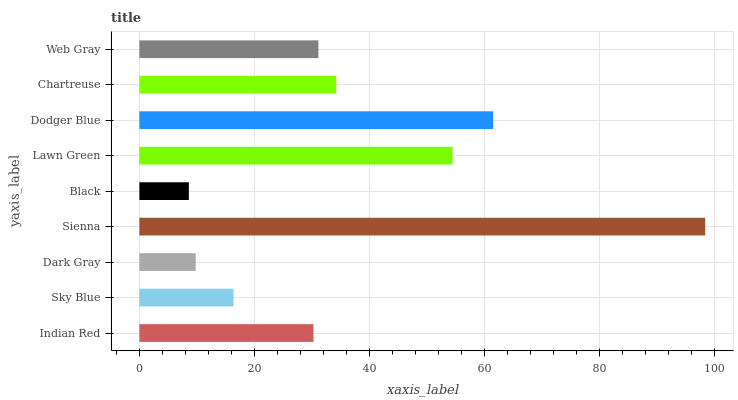Is Black the minimum?
Answer yes or no. Yes. Is Sienna the maximum?
Answer yes or no. Yes. Is Sky Blue the minimum?
Answer yes or no. No. Is Sky Blue the maximum?
Answer yes or no. No. Is Indian Red greater than Sky Blue?
Answer yes or no. Yes. Is Sky Blue less than Indian Red?
Answer yes or no. Yes. Is Sky Blue greater than Indian Red?
Answer yes or no. No. Is Indian Red less than Sky Blue?
Answer yes or no. No. Is Web Gray the high median?
Answer yes or no. Yes. Is Web Gray the low median?
Answer yes or no. Yes. Is Sky Blue the high median?
Answer yes or no. No. Is Lawn Green the low median?
Answer yes or no. No. 